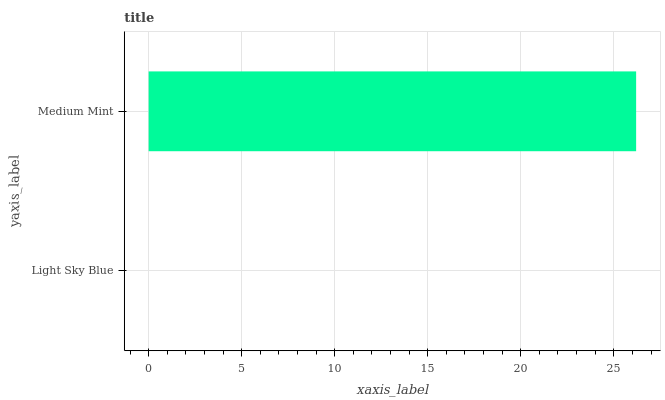Is Light Sky Blue the minimum?
Answer yes or no. Yes. Is Medium Mint the maximum?
Answer yes or no. Yes. Is Medium Mint the minimum?
Answer yes or no. No. Is Medium Mint greater than Light Sky Blue?
Answer yes or no. Yes. Is Light Sky Blue less than Medium Mint?
Answer yes or no. Yes. Is Light Sky Blue greater than Medium Mint?
Answer yes or no. No. Is Medium Mint less than Light Sky Blue?
Answer yes or no. No. Is Medium Mint the high median?
Answer yes or no. Yes. Is Light Sky Blue the low median?
Answer yes or no. Yes. Is Light Sky Blue the high median?
Answer yes or no. No. Is Medium Mint the low median?
Answer yes or no. No. 